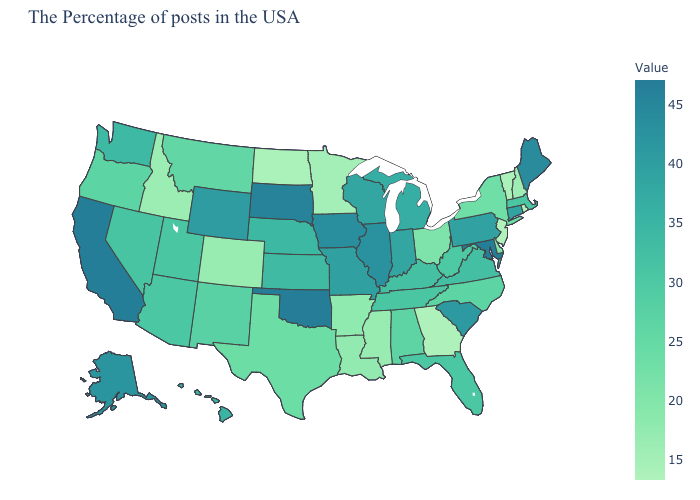Which states have the highest value in the USA?
Short answer required. Oklahoma. Does Tennessee have a lower value than South Carolina?
Short answer required. Yes. Does Idaho have the lowest value in the West?
Answer briefly. Yes. Among the states that border Nevada , does Idaho have the lowest value?
Be succinct. Yes. Among the states that border New York , does New Jersey have the lowest value?
Keep it brief. Yes. Which states hav the highest value in the MidWest?
Write a very short answer. South Dakota. 